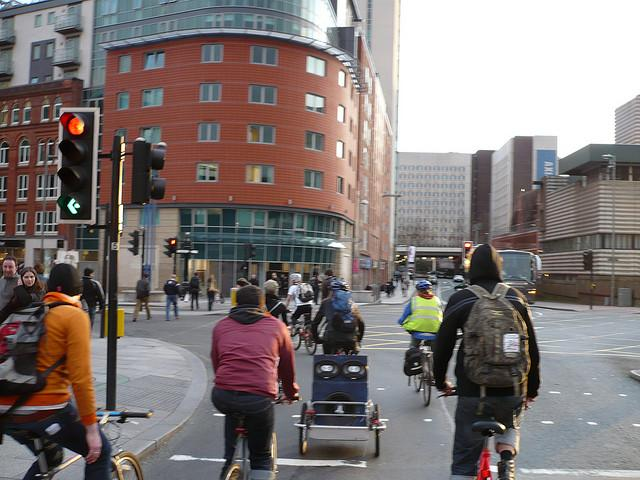What type of action is allowed by the traffic light? Please explain your reasoning. left turn. The action is to turn left. 